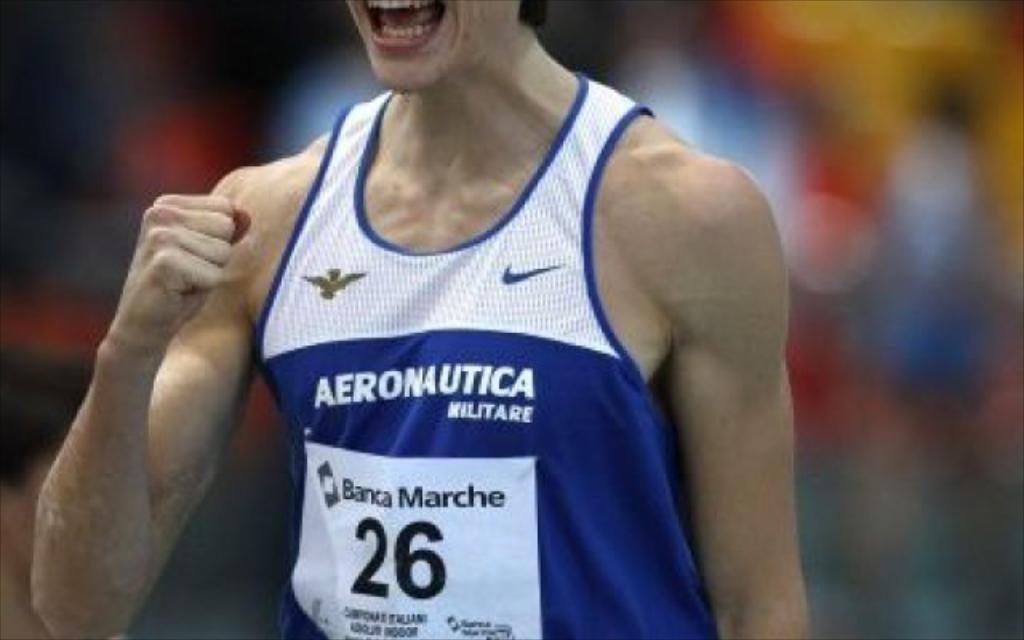<image>
Relay a brief, clear account of the picture shown. A sports player has numer 26 writen on the front of his jersey. 